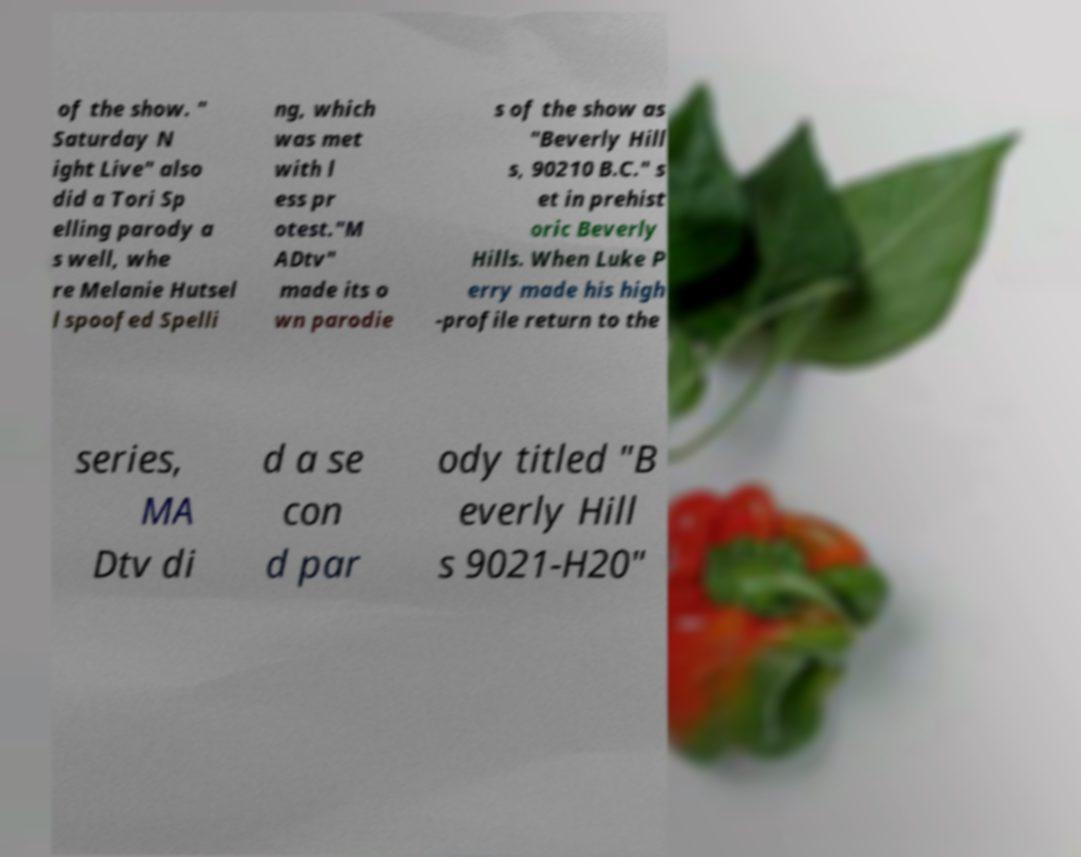Can you accurately transcribe the text from the provided image for me? of the show. " Saturday N ight Live" also did a Tori Sp elling parody a s well, whe re Melanie Hutsel l spoofed Spelli ng, which was met with l ess pr otest."M ADtv" made its o wn parodie s of the show as "Beverly Hill s, 90210 B.C." s et in prehist oric Beverly Hills. When Luke P erry made his high -profile return to the series, MA Dtv di d a se con d par ody titled "B everly Hill s 9021-H20" 